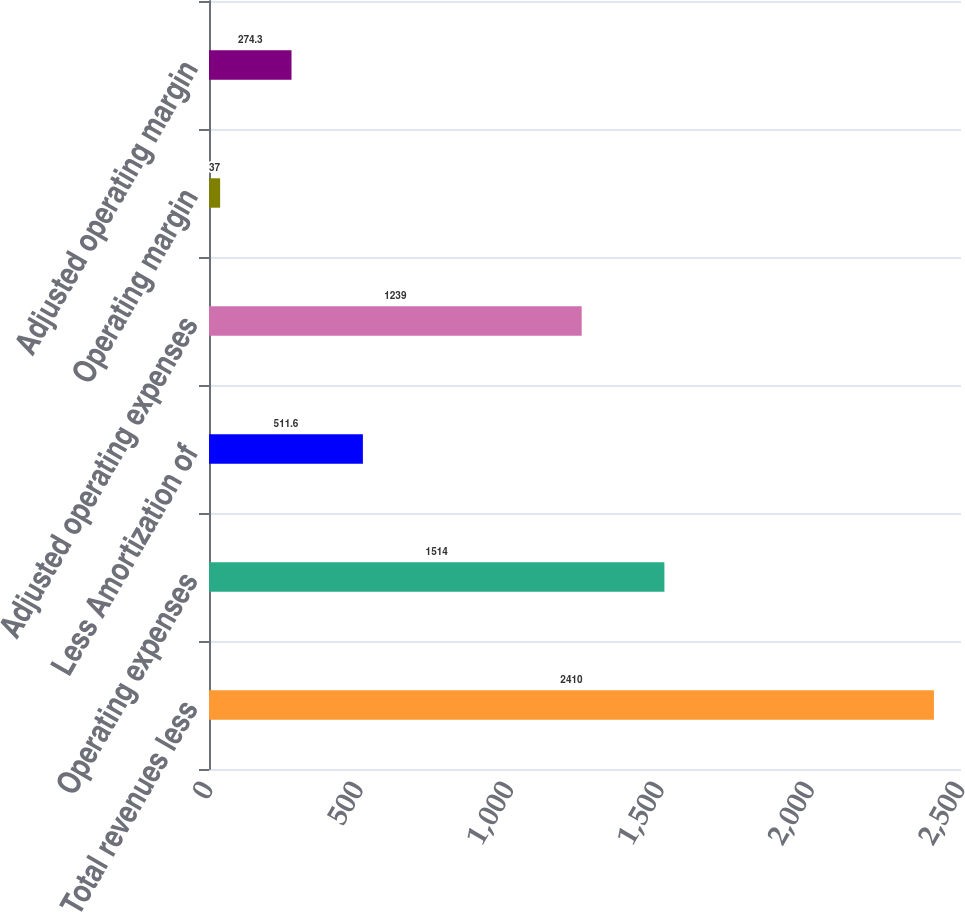Convert chart. <chart><loc_0><loc_0><loc_500><loc_500><bar_chart><fcel>Total revenues less<fcel>Operating expenses<fcel>Less Amortization of<fcel>Adjusted operating expenses<fcel>Operating margin<fcel>Adjusted operating margin<nl><fcel>2410<fcel>1514<fcel>511.6<fcel>1239<fcel>37<fcel>274.3<nl></chart> 